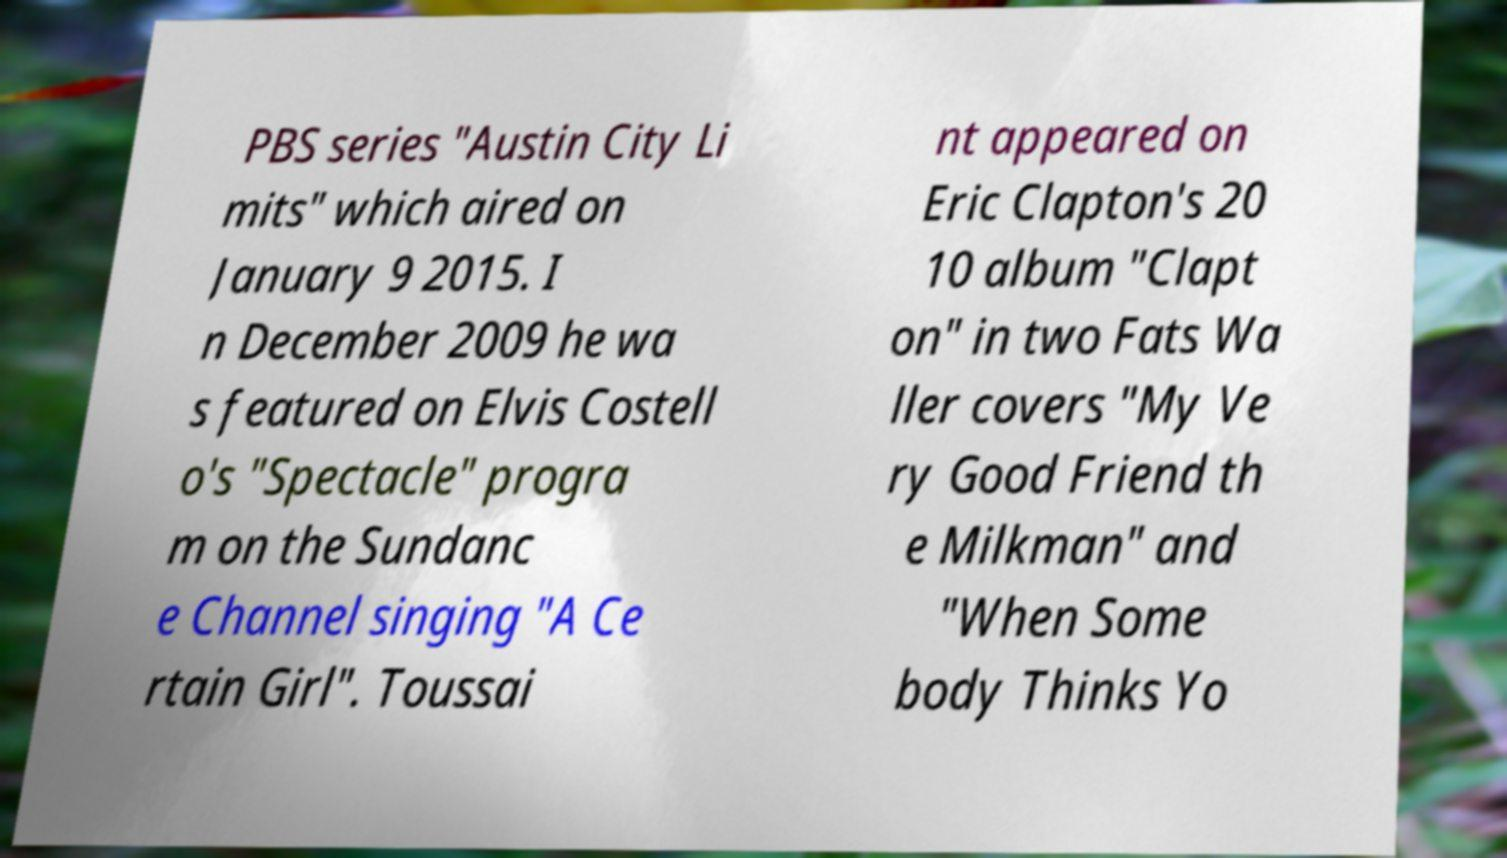Can you accurately transcribe the text from the provided image for me? PBS series "Austin City Li mits" which aired on January 9 2015. I n December 2009 he wa s featured on Elvis Costell o's "Spectacle" progra m on the Sundanc e Channel singing "A Ce rtain Girl". Toussai nt appeared on Eric Clapton's 20 10 album "Clapt on" in two Fats Wa ller covers "My Ve ry Good Friend th e Milkman" and "When Some body Thinks Yo 